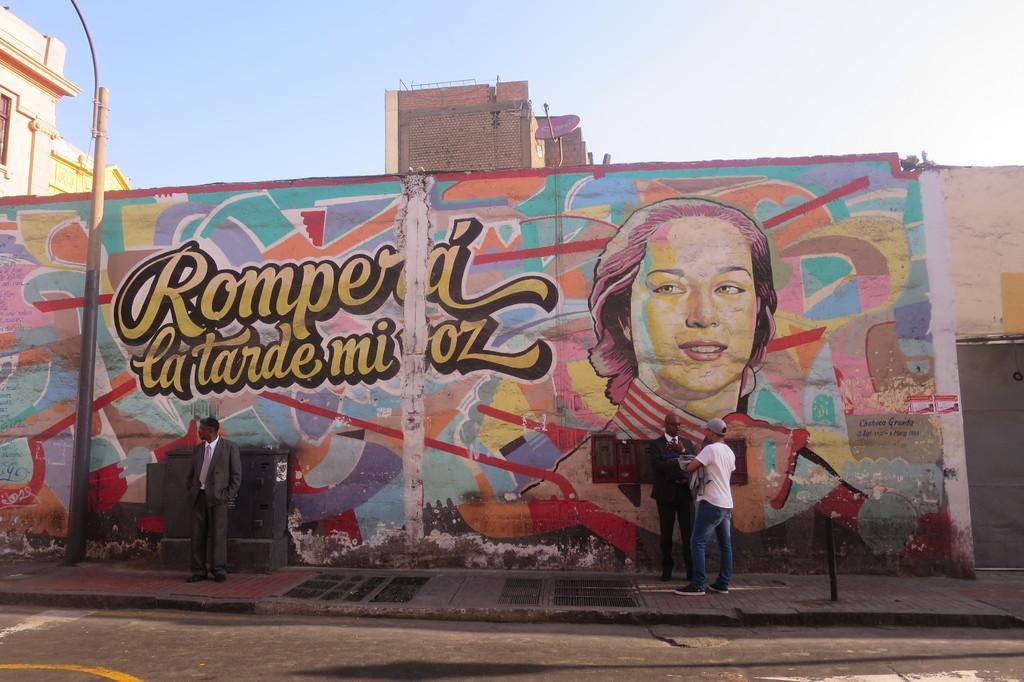How would you summarize this image in a sentence or two? In the image we can see there are people standing, wearing clothes and shoes. Here we can see the wall and painting on the wall. Here we can see the pole, road and the sky. 